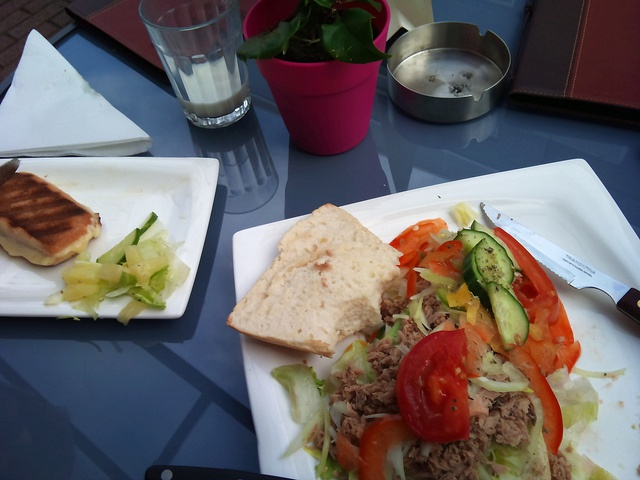Describe the objects in this image and their specific colors. I can see dining table in black, lightgray, darkblue, and navy tones, sandwich in black, maroon, and olive tones, sandwich in black, tan, and gray tones, potted plant in black, maroon, and purple tones, and cup in black, gray, and darkgray tones in this image. 